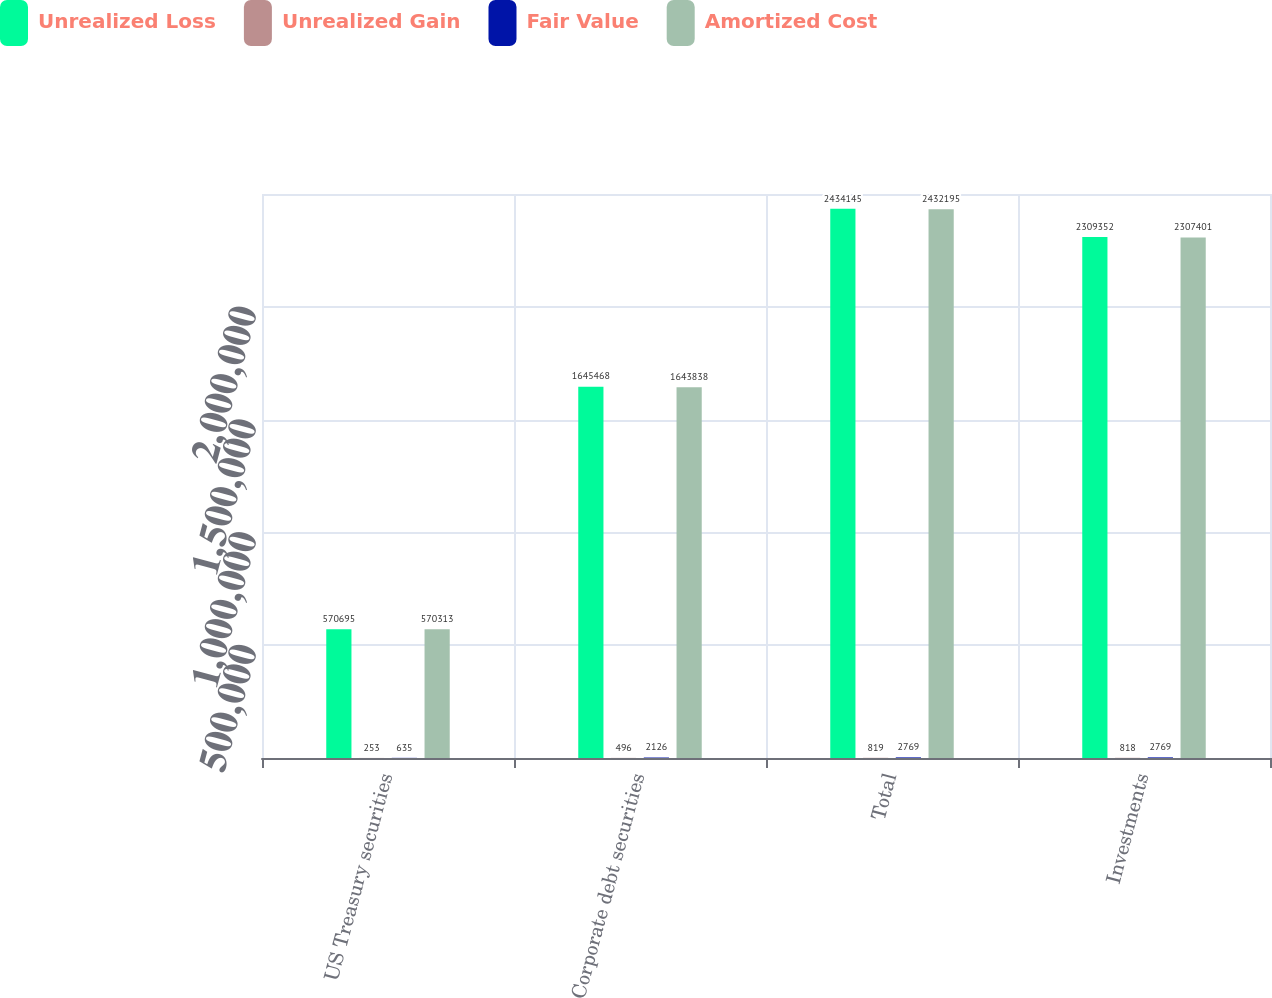Convert chart to OTSL. <chart><loc_0><loc_0><loc_500><loc_500><stacked_bar_chart><ecel><fcel>US Treasury securities<fcel>Corporate debt securities<fcel>Total<fcel>Investments<nl><fcel>Unrealized Loss<fcel>570695<fcel>1.64547e+06<fcel>2.43414e+06<fcel>2.30935e+06<nl><fcel>Unrealized Gain<fcel>253<fcel>496<fcel>819<fcel>818<nl><fcel>Fair Value<fcel>635<fcel>2126<fcel>2769<fcel>2769<nl><fcel>Amortized Cost<fcel>570313<fcel>1.64384e+06<fcel>2.4322e+06<fcel>2.3074e+06<nl></chart> 